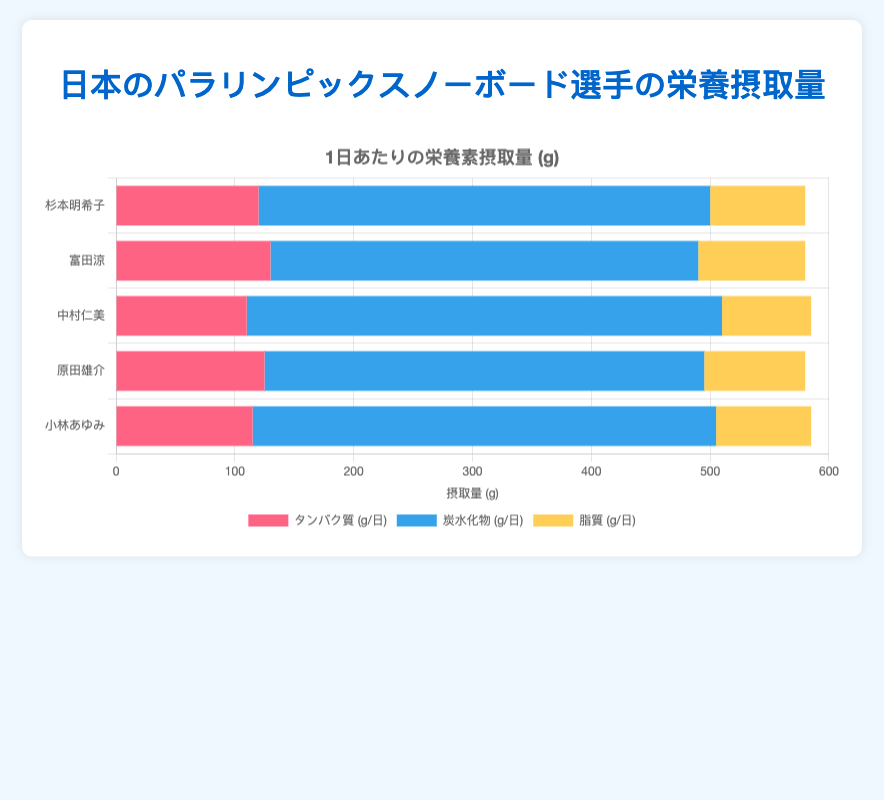Which Paralympian consumes the most carbohydrates per day? Look at the lengths of the carbohydrate segments (blue color) in the horizontal stacked bars. Hitomi Nakamura has the longest blue segment, indicating the highest carbohydrate consumption.
Answer: Hitomi Nakamura How many grams of proteins and fats does Yusuke Harada consume per day combatively? Sum the values for proteins and fats for Yusuke Harada: 125g (proteins) + 85g (fats) = 210g.
Answer: 210g Which Paralympian has the least intake of fats per day? Examine the lengths of the fat segments (yellow color) in the bars. Hitomi Nakamura has the shortest yellow segment, indicating the lowest fat intake.
Answer: Hitomi Nakamura What's the average daily intake of carbohydrates among the Paralympians listed? Add the carbohydrate values for all Paralympians: 380 + 360 + 400 + 370 + 390 = 1900; then divide by the number of Paralympians: 1900/5 = 380g.
Answer: 380g Is Akiko Sugimoto's protein consumption higher or lower than the average protein consumption among the listed Paralympians? Calculate the average protein intake: (120 + 130 + 110 + 125 + 115) / 5 = 120g; Compare it with Akiko Sugimoto's protein intake (120g).
Answer: Equal How many total grams of nutrients does Ayumi Kobayashi consume per day? Add the values for proteins, carbohydrates, and fats for Ayumi Kobayashi: 115g + 390g + 80g = 585g.
Answer: 585g Which nutrient has the widest overall bar length when combined across all Paralympians? Observe the total extensions of each nutrient's segments. Carbohydrates (blue) segments extend the longest visually compared to proteins (red) and fats (yellow).
Answer: Carbohydrates Which Paralympian has the lowest intake of proteins and what is the amount? Check the protein (red) segments and compare their lengths; Hitomi Nakamura's segment is the shortest.
Answer: Hitomi Nakamura, 110g Rank the Paralympians by their total intake of fats from highest to lowest. Compare the yellow segments of each bar to rank by total fat intake: Ryo Tomita (90g), Yusuke Harada (85g), Akiko Sugimoto (80g), Ayumi Kobayashi (80g), Hitomi Nakamura (75g).
Answer: Ryo Tomita, Yusuke Harada, Akiko Sugimoto, Ayumi Kobayashi, Hitomi Nakamura 